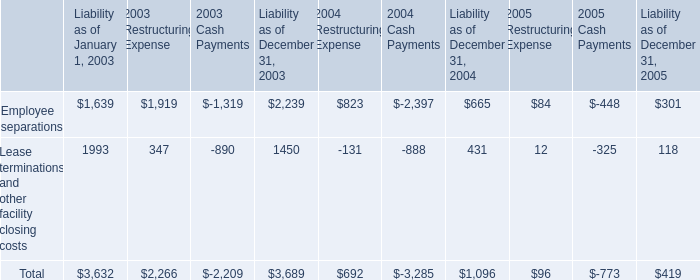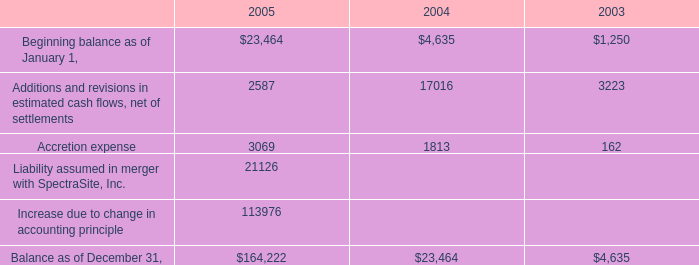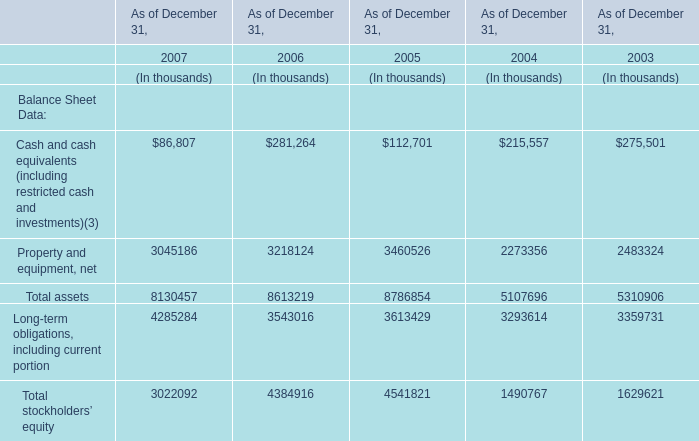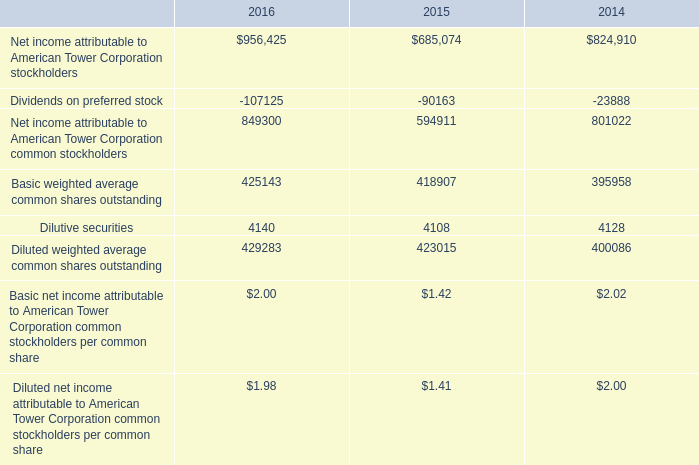what's the total amount of Beginning balance as of January 1, of 2005, and Employee separations of 2004 Cash Payments ? 
Computations: (23464.0 + 2397.0)
Answer: 25861.0. 